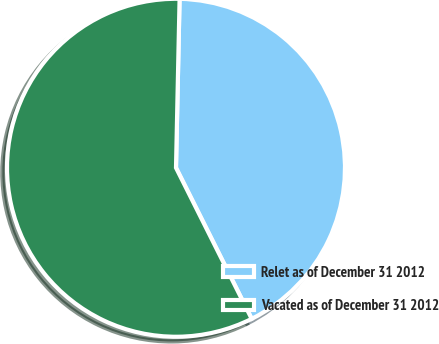<chart> <loc_0><loc_0><loc_500><loc_500><pie_chart><fcel>Relet as of December 31 2012<fcel>Vacated as of December 31 2012<nl><fcel>42.27%<fcel>57.73%<nl></chart> 